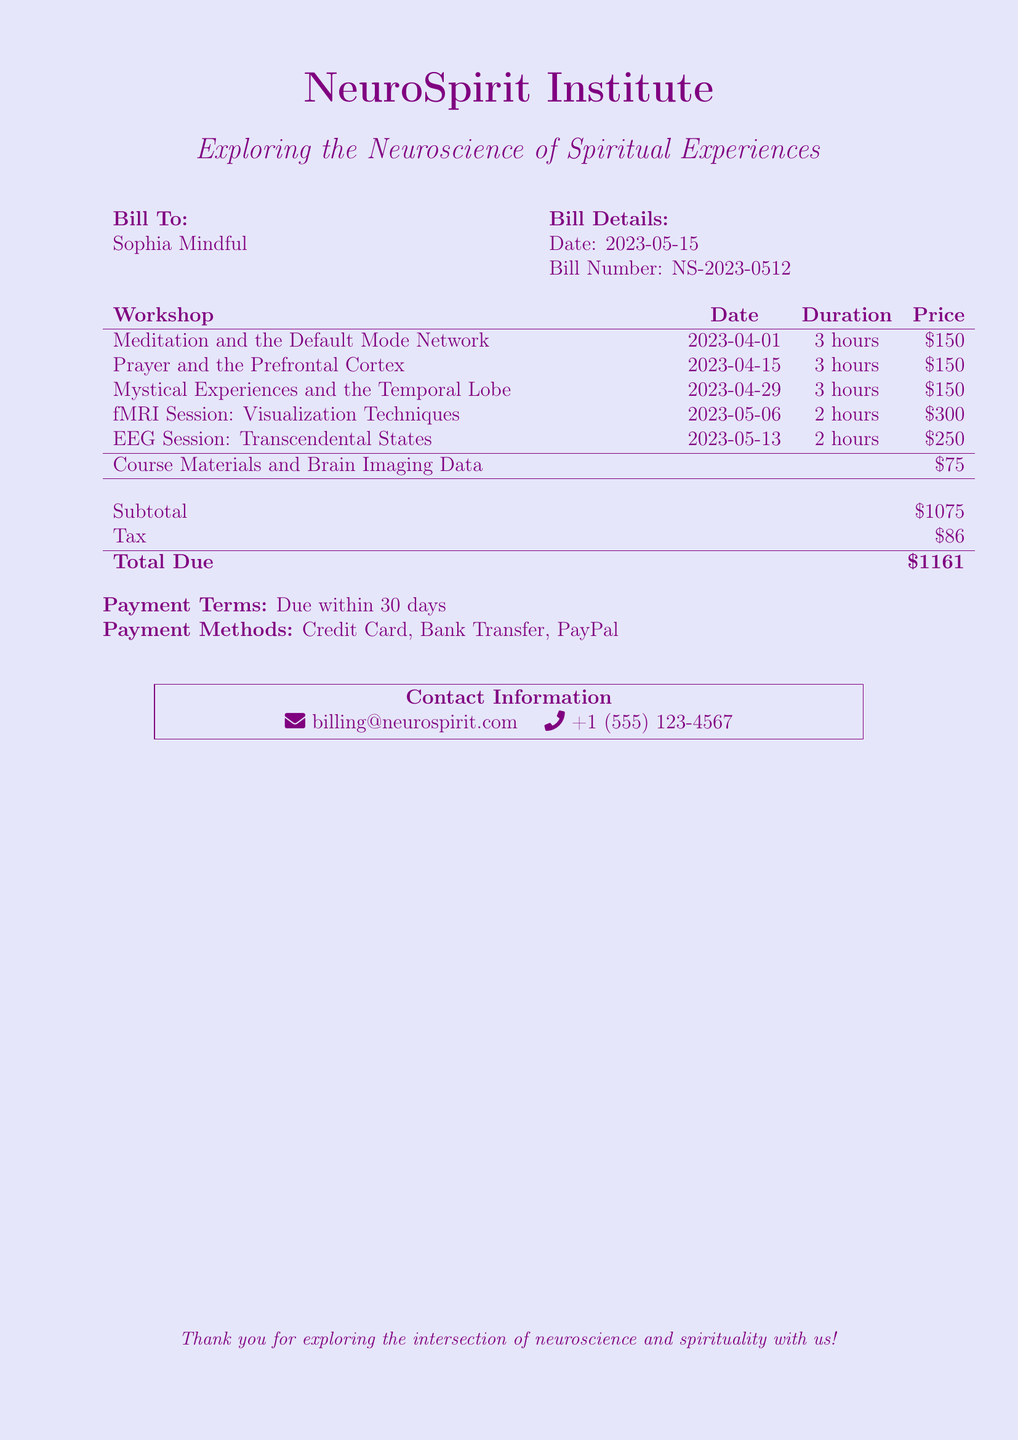What is the bill number? The bill number is specified in the document under "Bill Details."
Answer: NS-2023-0512 What is the total due amount? The total due is calculated from the subtotal and tax in the document.
Answer: $1161 What is the duration of the "Prayer and the Prefrontal Cortex" workshop? The duration of each workshop is listed in the corresponding row of the workshop table.
Answer: 3 hours How much does the fMRI session cost? The cost is indicated in the same workshop table where the fMRI session is listed.
Answer: $300 What date was the first workshop held? The date of the first workshop is listed in the document in the workshops table.
Answer: 2023-04-01 What is required for payment methods? The document lists the available payment methods for settling the bill.
Answer: Credit Card, Bank Transfer, PayPal How many workshops are detailed in the bill? The document includes a list of workshops, and counting them gives the total number.
Answer: 5 What is the subtotal amount before tax? The subtotal is explicitly stated in the document before the tax is added.
Answer: $1075 What is the email contact provided in the document? The contact information section includes an email address for inquiries.
Answer: billing@neurospirit.com 